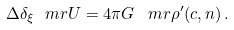<formula> <loc_0><loc_0><loc_500><loc_500>\Delta \delta _ { \xi } \ m r { U } = 4 \pi G \, \ m r { \rho } ^ { \prime } ( c , n ) \, .</formula> 